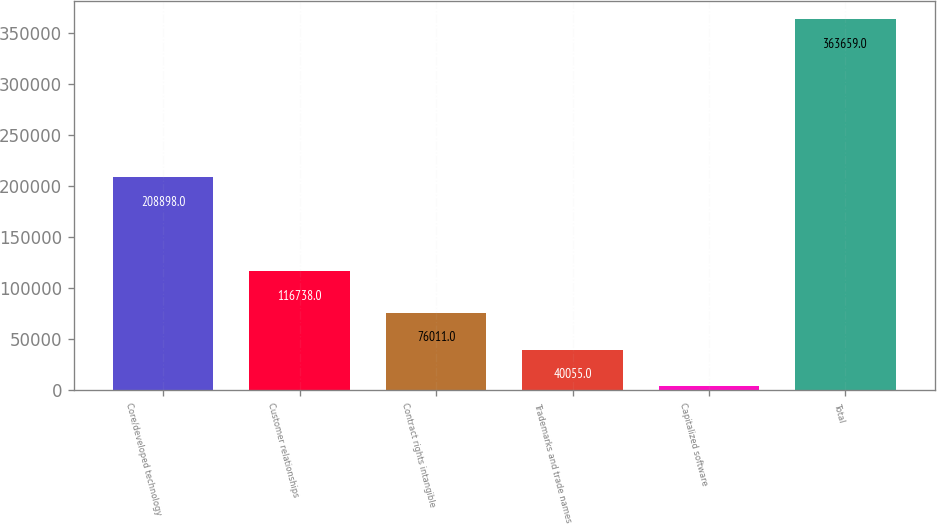Convert chart. <chart><loc_0><loc_0><loc_500><loc_500><bar_chart><fcel>Core/developed technology<fcel>Customer relationships<fcel>Contract rights intangible<fcel>Trademarks and trade names<fcel>Capitalized software<fcel>Total<nl><fcel>208898<fcel>116738<fcel>76011<fcel>40055<fcel>4099<fcel>363659<nl></chart> 